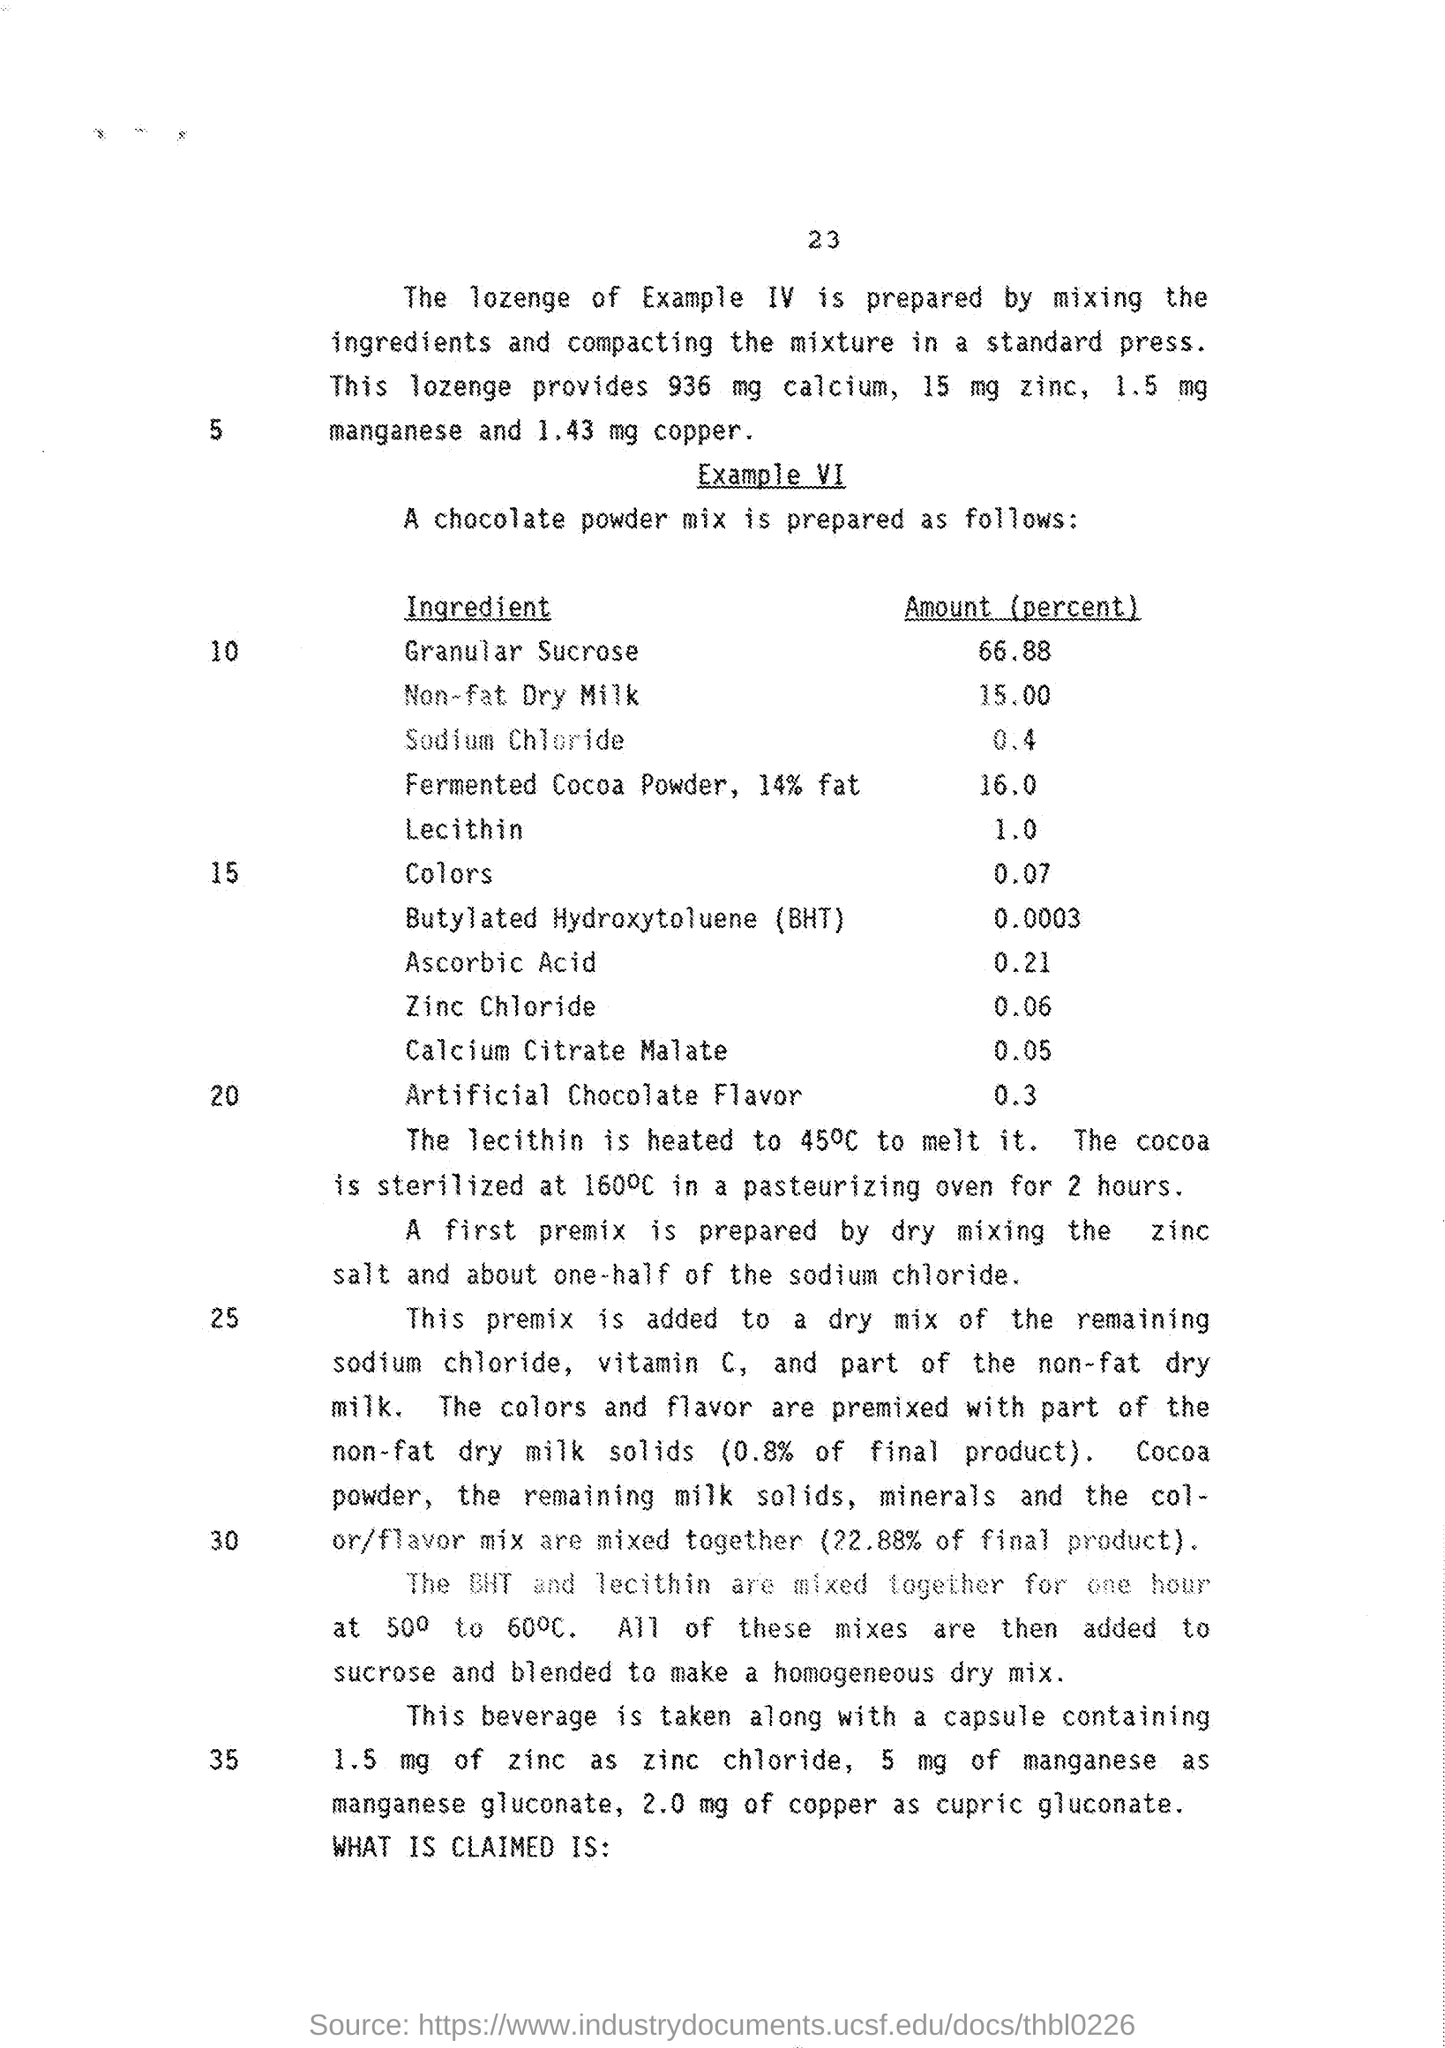Give some essential details in this illustration. The BHT and lecithin are mixed together for a duration of one hour, as mentioned in number 30. The amount of lecithin in this product is (at least) 1.0%. The quantity of copper provided by lozenges is 1.43 mg. The amount of ingredient "Zinc Chloride" provided is 0.06%. The amount of Ascorbic acid provided is 0.21%. 